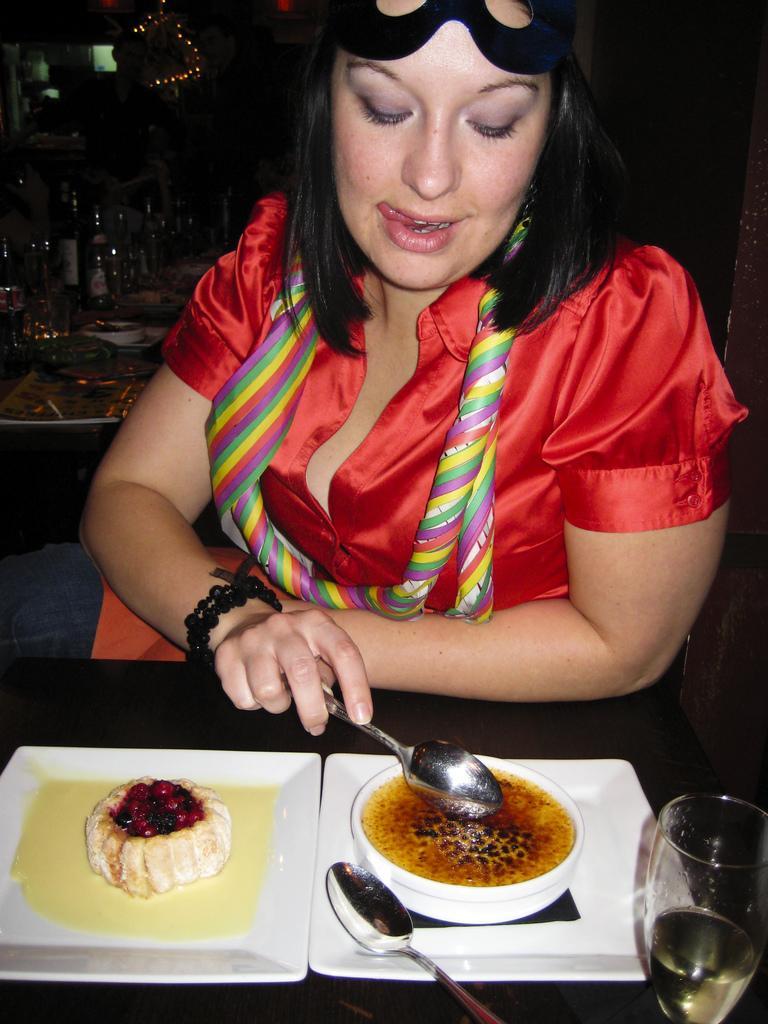In one or two sentences, can you explain what this image depicts? In this image in the middle there is a woman visible in front of the table, on the table there are two plates, on which there is a cake piece, bowl contain a liquid, woman holding a spoon, there is another spoon visible on the plate, glass contain a liquid kept on the table, behind the woman, in the top left may be there is a table, on which there are bottles visible. 